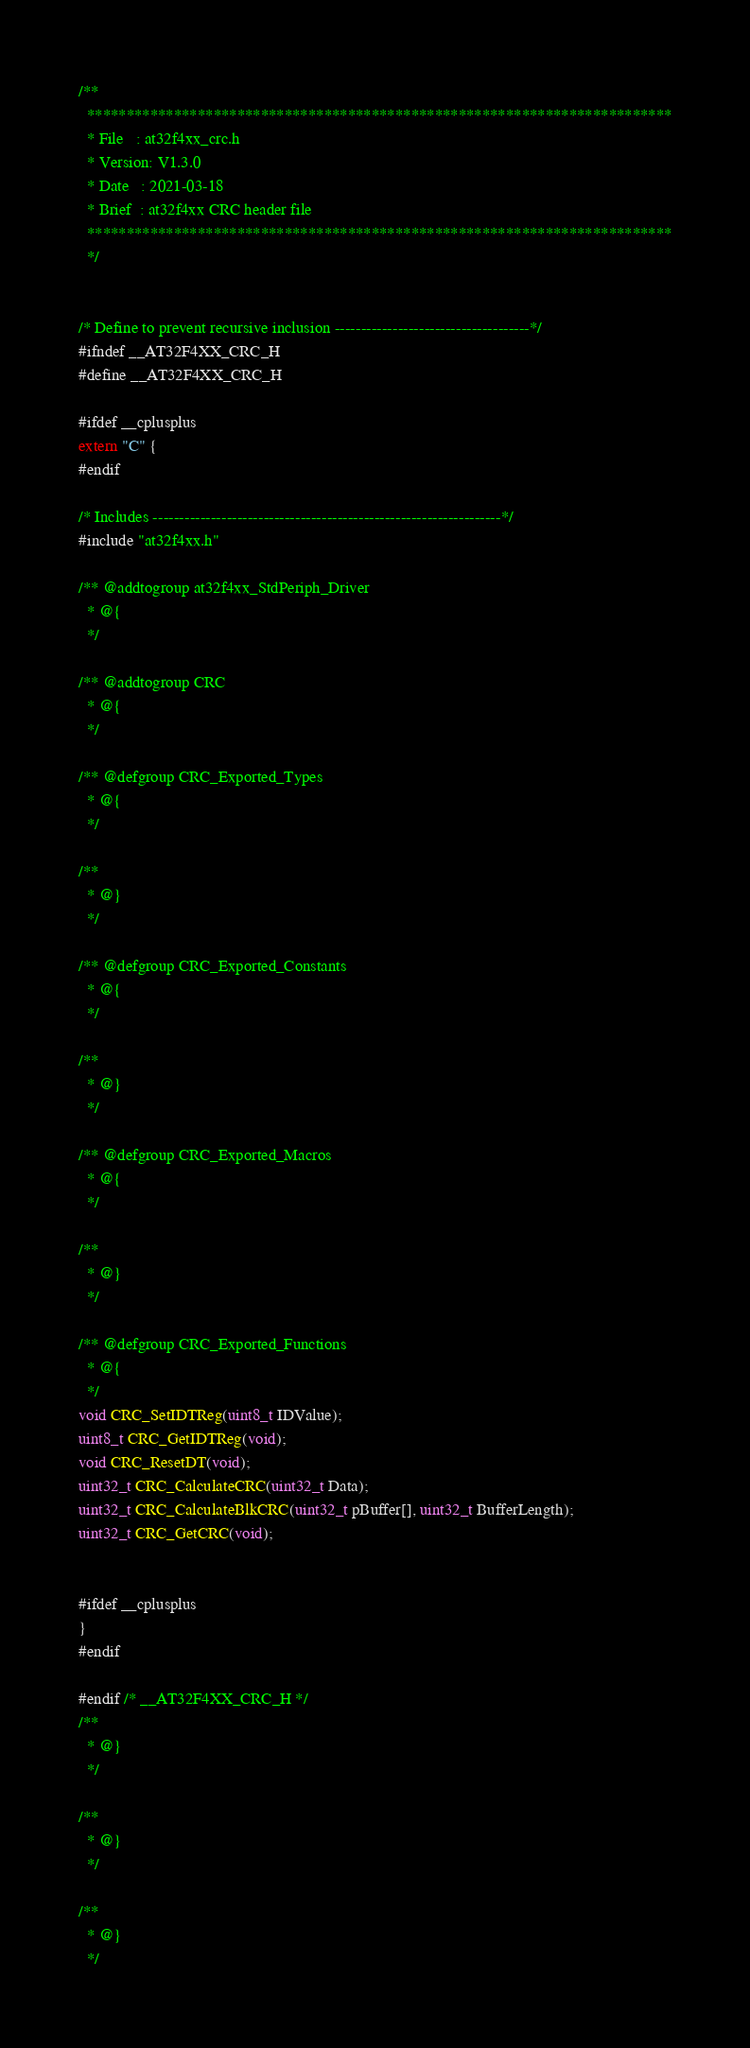<code> <loc_0><loc_0><loc_500><loc_500><_C_>/**
  **************************************************************************
  * File   : at32f4xx_crc.h
  * Version: V1.3.0
  * Date   : 2021-03-18
  * Brief  : at32f4xx CRC header file
  **************************************************************************
  */


/* Define to prevent recursive inclusion -------------------------------------*/
#ifndef __AT32F4XX_CRC_H
#define __AT32F4XX_CRC_H

#ifdef __cplusplus
extern "C" {
#endif

/* Includes ------------------------------------------------------------------*/
#include "at32f4xx.h"

/** @addtogroup at32f4xx_StdPeriph_Driver
  * @{
  */

/** @addtogroup CRC
  * @{
  */

/** @defgroup CRC_Exported_Types
  * @{
  */

/**
  * @}
  */

/** @defgroup CRC_Exported_Constants
  * @{
  */

/**
  * @}
  */

/** @defgroup CRC_Exported_Macros
  * @{
  */

/**
  * @}
  */

/** @defgroup CRC_Exported_Functions
  * @{
  */
void CRC_SetIDTReg(uint8_t IDValue);
uint8_t CRC_GetIDTReg(void);
void CRC_ResetDT(void);
uint32_t CRC_CalculateCRC(uint32_t Data);
uint32_t CRC_CalculateBlkCRC(uint32_t pBuffer[], uint32_t BufferLength);
uint32_t CRC_GetCRC(void);


#ifdef __cplusplus
}
#endif

#endif /* __AT32F4XX_CRC_H */
/**
  * @}
  */

/**
  * @}
  */

/**
  * @}
  */


</code> 